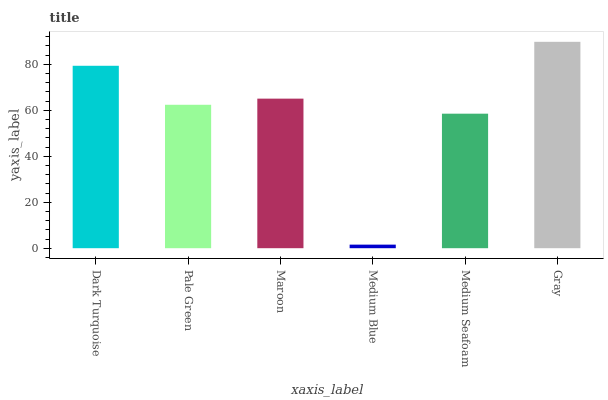Is Medium Blue the minimum?
Answer yes or no. Yes. Is Gray the maximum?
Answer yes or no. Yes. Is Pale Green the minimum?
Answer yes or no. No. Is Pale Green the maximum?
Answer yes or no. No. Is Dark Turquoise greater than Pale Green?
Answer yes or no. Yes. Is Pale Green less than Dark Turquoise?
Answer yes or no. Yes. Is Pale Green greater than Dark Turquoise?
Answer yes or no. No. Is Dark Turquoise less than Pale Green?
Answer yes or no. No. Is Maroon the high median?
Answer yes or no. Yes. Is Pale Green the low median?
Answer yes or no. Yes. Is Pale Green the high median?
Answer yes or no. No. Is Medium Blue the low median?
Answer yes or no. No. 